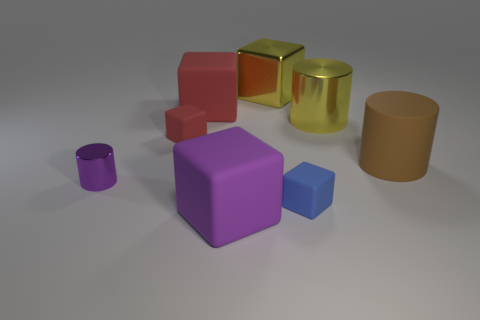Subtract all blue blocks. How many blocks are left? 4 Subtract all yellow cubes. How many cubes are left? 4 Subtract all cyan blocks. Subtract all brown cylinders. How many blocks are left? 5 Add 1 matte blocks. How many objects exist? 9 Subtract all cubes. How many objects are left? 3 Subtract 1 brown cylinders. How many objects are left? 7 Subtract all small red objects. Subtract all shiny blocks. How many objects are left? 6 Add 4 brown objects. How many brown objects are left? 5 Add 7 red matte cubes. How many red matte cubes exist? 9 